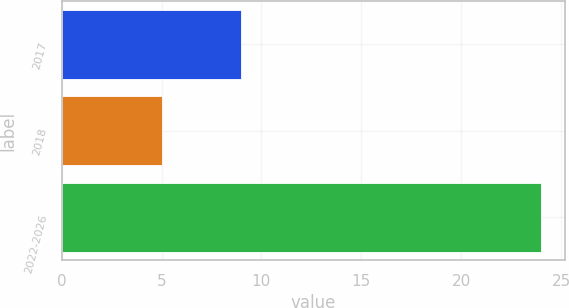<chart> <loc_0><loc_0><loc_500><loc_500><bar_chart><fcel>2017<fcel>2018<fcel>2022-2026<nl><fcel>9<fcel>5<fcel>24<nl></chart> 